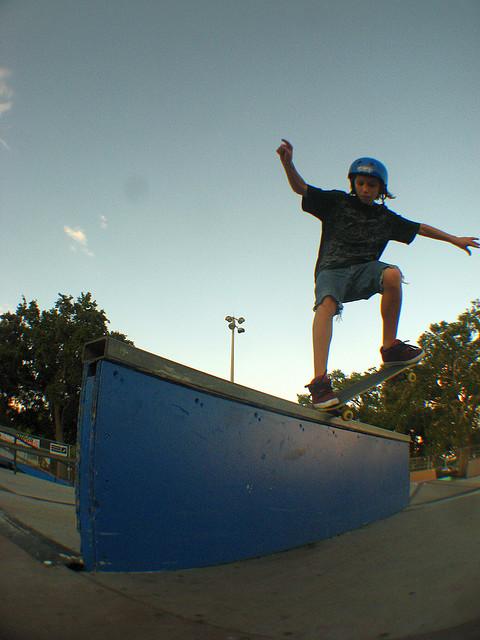Is there graffiti on the wall?
Concise answer only. No. Is the skateboarder doing a trick?
Give a very brief answer. Yes. What color is the shirt?
Write a very short answer. Black. Is the skateboarder wearing knee pads?
Short answer required. No. Is there a vehicle?
Be succinct. No. What is being worn on the knees?
Short answer required. Nothing. What is the color of the wall?
Quick response, please. Blue. What is the name of the trick that the kid is doing?
Concise answer only. Grinding. 